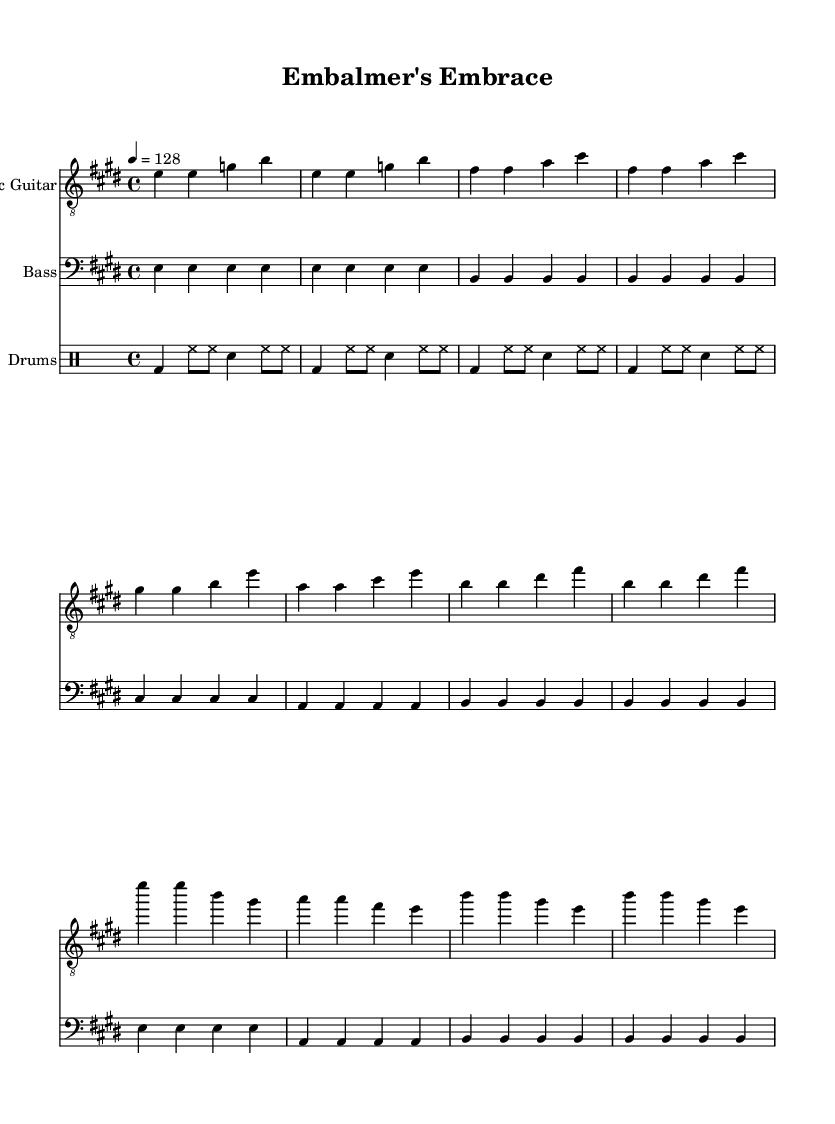What is the key signature of this music? The key signature is E major, which includes four sharps: F#, C#, G#, and D#. This can be identified at the beginning of the music sheet, indicated on the staff.
Answer: E major What is the time signature of this music? The time signature shown in the music sheet is 4/4, meaning there are four beats per measure, and the quarter note gets one beat. This is noted at the beginning of the sheet music.
Answer: 4/4 What is the tempo marking of this music? The tempo marking is 128 beats per minute, indicated by the notation "4 = 128" at the top of the music sheet. This tells the performer to play at a moderately fast pace.
Answer: 128 What instruments are included in this music? The instruments indicated in the score are Electric Guitar, Bass, and Drums, as shown at the beginning of each staff. Each instrument has its own musical part clearly labeled.
Answer: Electric Guitar, Bass, Drums What is the mood or theme suggested by the chorus lyrics? The chorus lyrics suggest a positive and uplifting theme focused on stress relief and rejuvenation, indicated by phrases like "Rock away the stress and strain" and "feel alive again." This reflects the upbeat nature typical of classic rock anthems.
Answer: Upbeat and uplifting How does the bass line in the Verse section primarily move? The bass line in the Verse moves primarily on the tonic and dominant notes (E and B), with each note played four times per measure, indicating a steady and grounding rhythm typical in rock music.
Answer: Tonic and dominant notes 